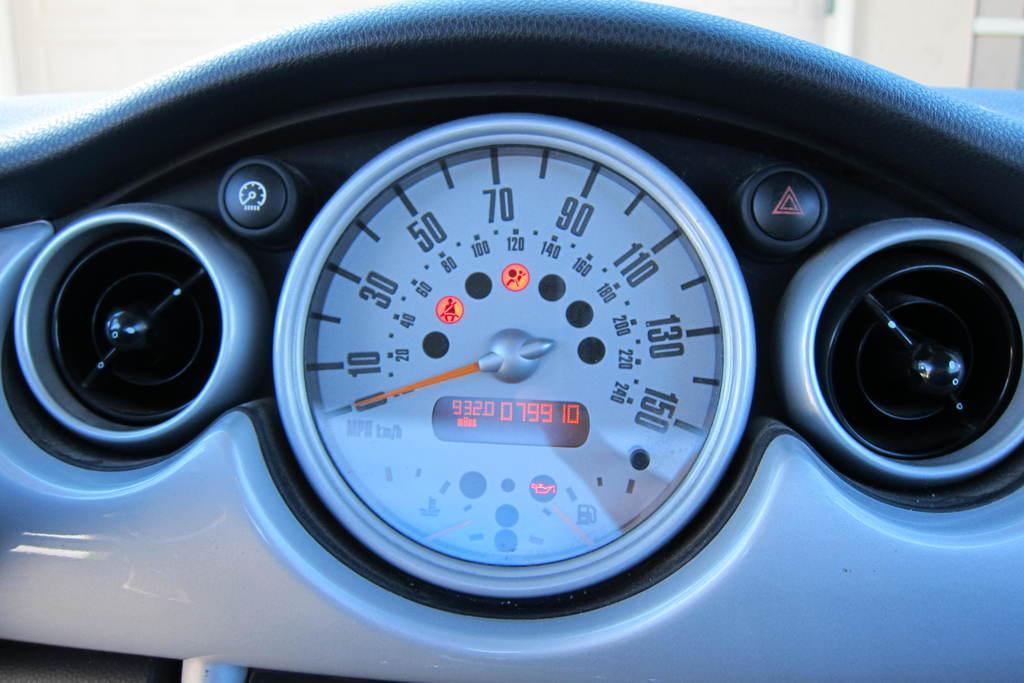In one or two sentences, can you explain what this image depicts? In this image we can see a speedometer and buttons of a vehicle. 